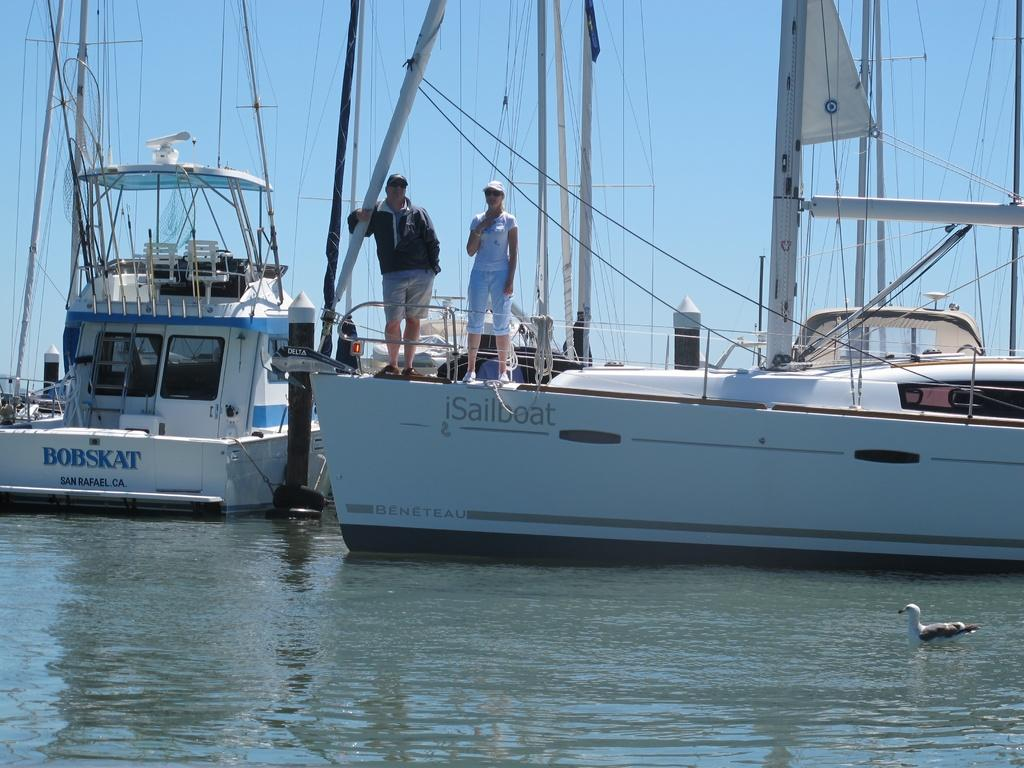Who is present in the image? There are people in the image. What are the people doing in the image? The people are on boats. What are the people wearing on their heads? The people are wearing caps. What is visible at the top of the image? There is sky visible at the top of the image. What can be seen on the water at the bottom of the image? There is a bird on the water at the bottom of the image. What type of cabbage is being harvested by the women in the image? There are no women or cabbage present in the image; it features people on boats wearing caps. 